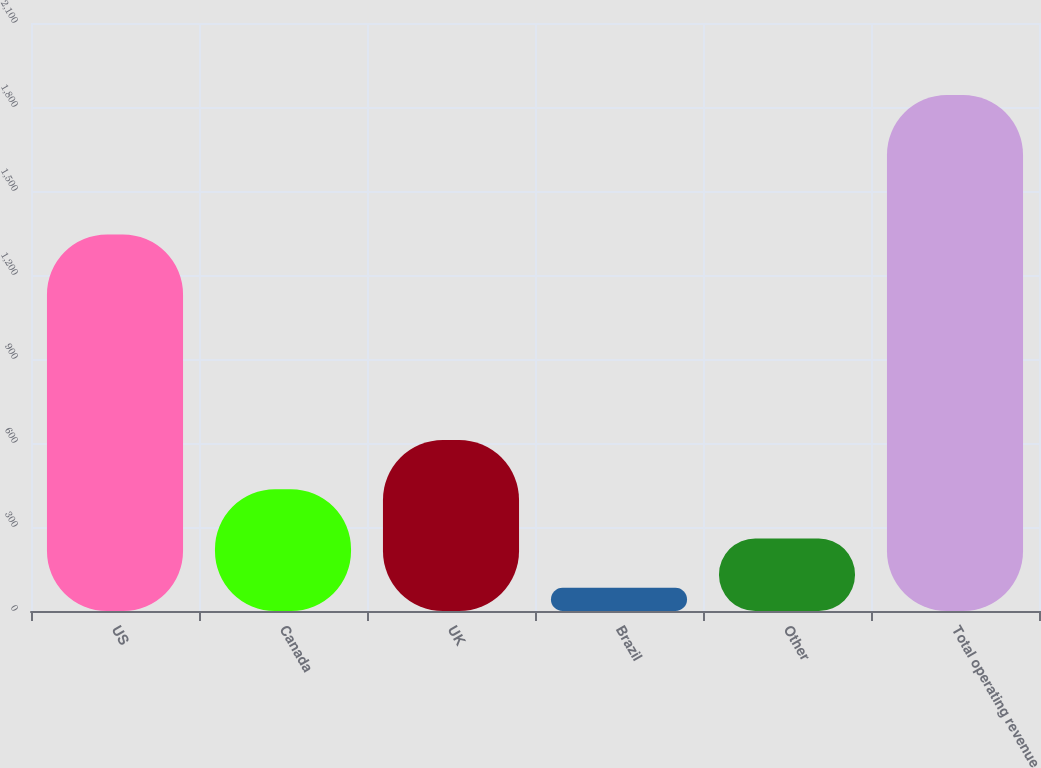Convert chart to OTSL. <chart><loc_0><loc_0><loc_500><loc_500><bar_chart><fcel>US<fcel>Canada<fcel>UK<fcel>Brazil<fcel>Other<fcel>Total operating revenue<nl><fcel>1344.5<fcel>435<fcel>611<fcel>83<fcel>259<fcel>1843<nl></chart> 